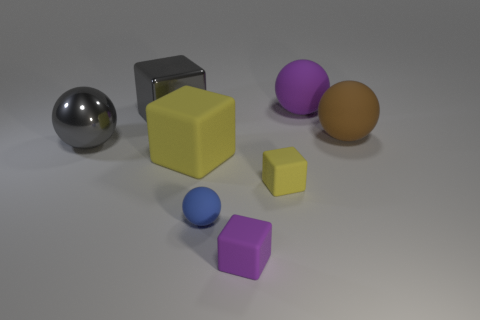What number of matte things are both to the left of the purple sphere and behind the small purple rubber thing?
Ensure brevity in your answer.  3. There is a purple block; what number of purple rubber things are in front of it?
Your answer should be compact. 0. Are there any gray things of the same shape as the big purple object?
Provide a succinct answer. Yes. Does the tiny yellow object have the same shape as the small object that is to the left of the purple matte block?
Keep it short and to the point. No. What number of spheres are red metal objects or purple objects?
Your answer should be very brief. 1. What shape is the large shiny object behind the brown rubber sphere?
Provide a short and direct response. Cube. What number of large yellow things have the same material as the brown thing?
Make the answer very short. 1. Are there fewer purple cubes that are in front of the blue ball than large brown objects?
Your response must be concise. No. What size is the object behind the shiny block that is left of the tiny yellow thing?
Provide a succinct answer. Large. There is a big metallic ball; is its color the same as the large matte object that is on the left side of the large purple ball?
Your answer should be compact. No. 